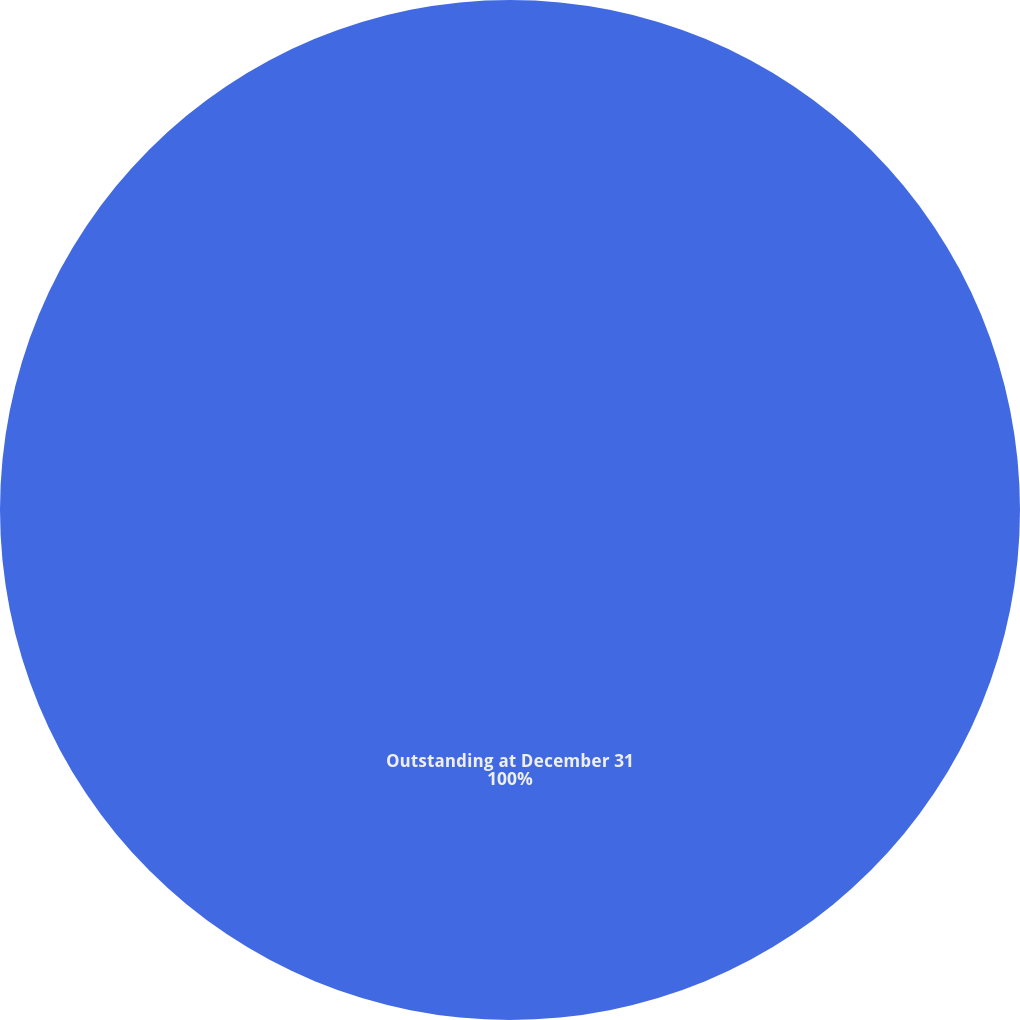Convert chart. <chart><loc_0><loc_0><loc_500><loc_500><pie_chart><fcel>Outstanding at December 31<nl><fcel>100.0%<nl></chart> 